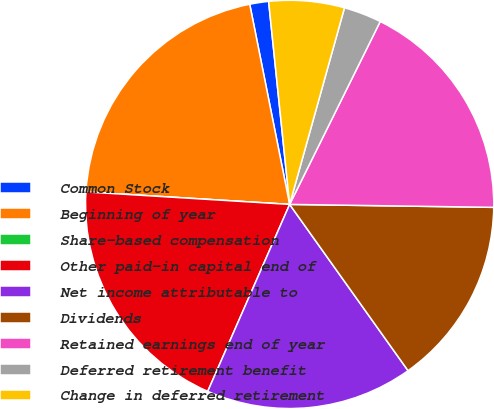Convert chart to OTSL. <chart><loc_0><loc_0><loc_500><loc_500><pie_chart><fcel>Common Stock<fcel>Beginning of year<fcel>Share-based compensation<fcel>Other paid-in capital end of<fcel>Net income attributable to<fcel>Dividends<fcel>Retained earnings end of year<fcel>Deferred retirement benefit<fcel>Change in deferred retirement<nl><fcel>1.49%<fcel>20.89%<fcel>0.0%<fcel>19.4%<fcel>16.42%<fcel>14.92%<fcel>17.91%<fcel>2.99%<fcel>5.97%<nl></chart> 